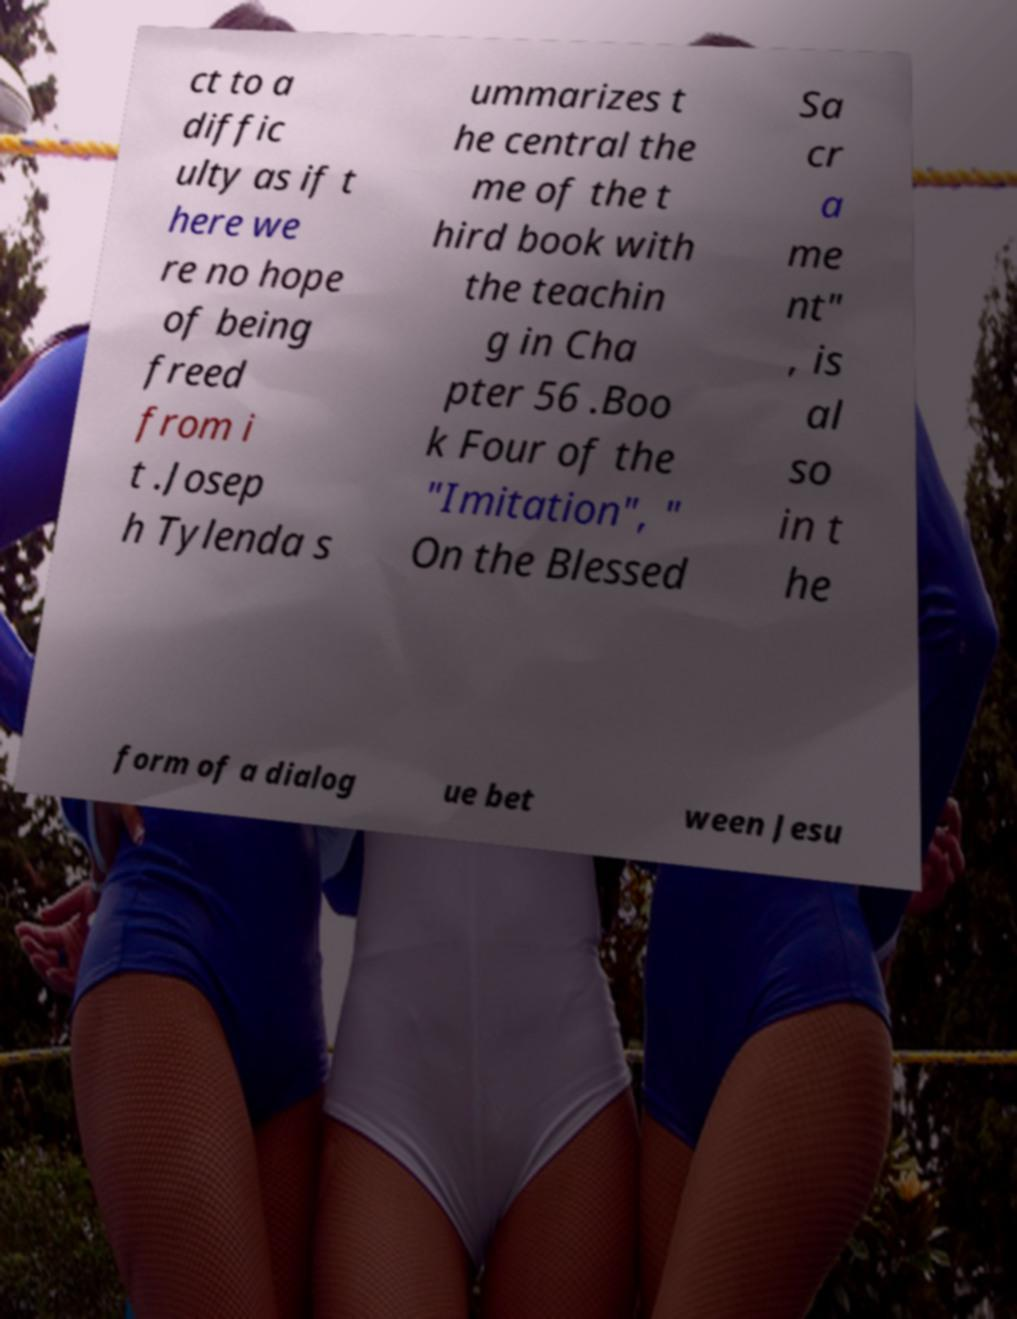Can you accurately transcribe the text from the provided image for me? ct to a diffic ulty as if t here we re no hope of being freed from i t .Josep h Tylenda s ummarizes t he central the me of the t hird book with the teachin g in Cha pter 56 .Boo k Four of the "Imitation", " On the Blessed Sa cr a me nt" , is al so in t he form of a dialog ue bet ween Jesu 